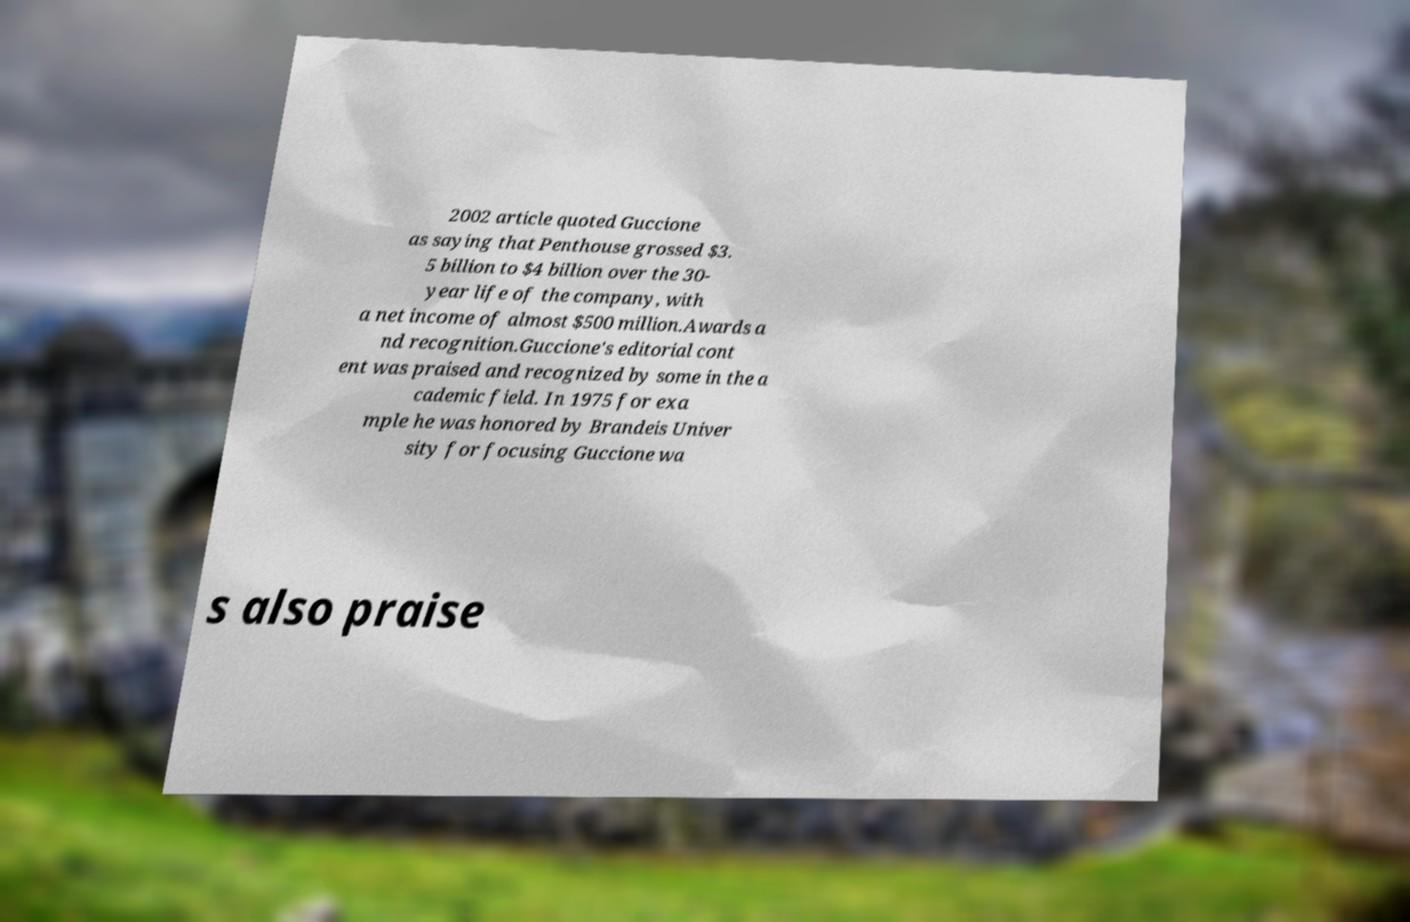Could you extract and type out the text from this image? 2002 article quoted Guccione as saying that Penthouse grossed $3. 5 billion to $4 billion over the 30- year life of the company, with a net income of almost $500 million.Awards a nd recognition.Guccione's editorial cont ent was praised and recognized by some in the a cademic field. In 1975 for exa mple he was honored by Brandeis Univer sity for focusing Guccione wa s also praise 